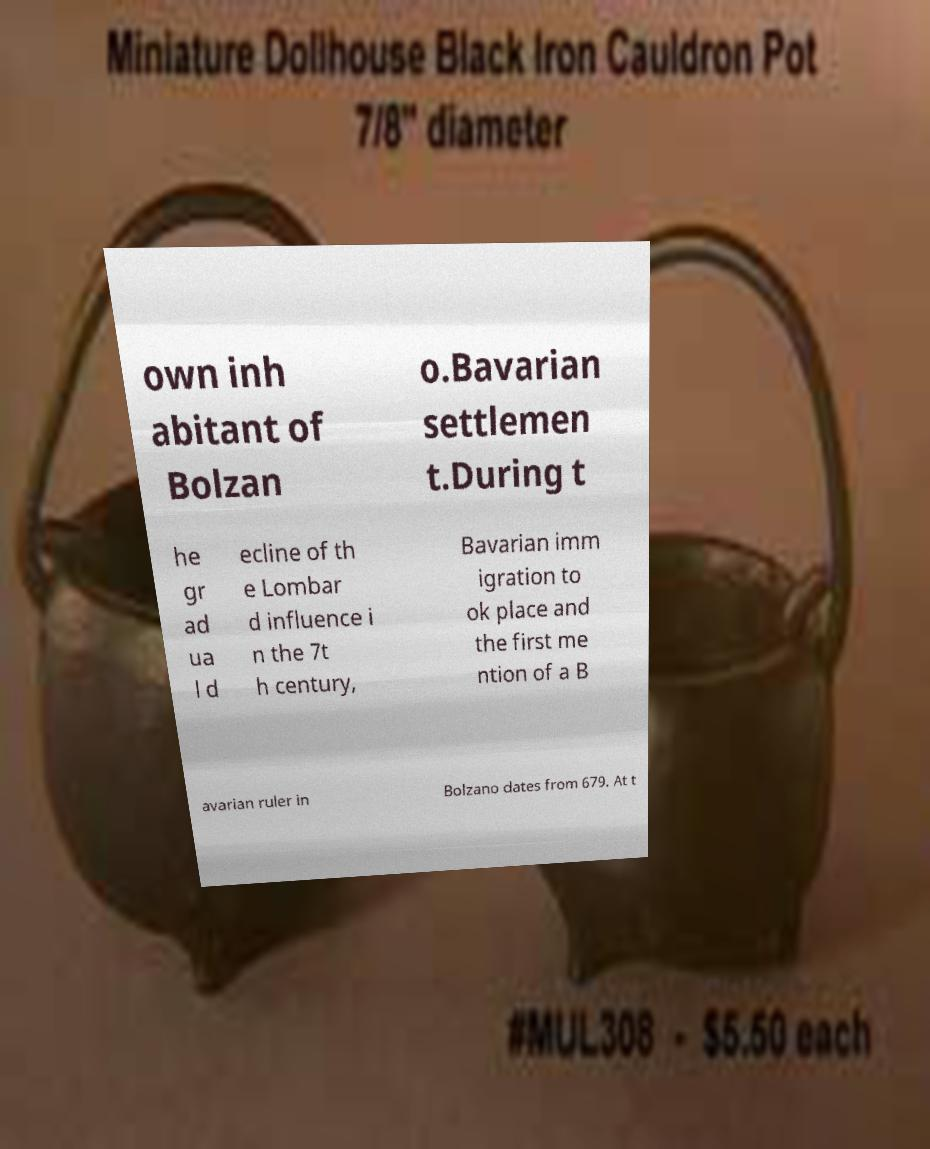There's text embedded in this image that I need extracted. Can you transcribe it verbatim? own inh abitant of Bolzan o.Bavarian settlemen t.During t he gr ad ua l d ecline of th e Lombar d influence i n the 7t h century, Bavarian imm igration to ok place and the first me ntion of a B avarian ruler in Bolzano dates from 679. At t 